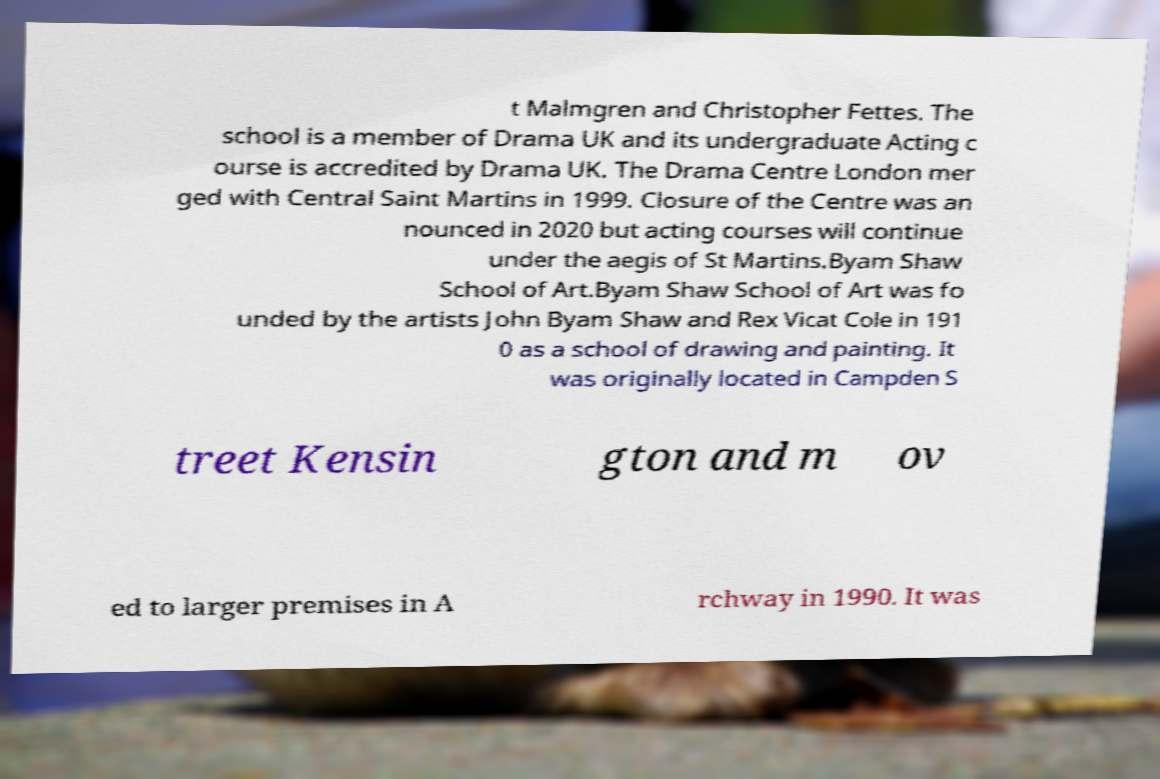There's text embedded in this image that I need extracted. Can you transcribe it verbatim? t Malmgren and Christopher Fettes. The school is a member of Drama UK and its undergraduate Acting c ourse is accredited by Drama UK. The Drama Centre London mer ged with Central Saint Martins in 1999. Closure of the Centre was an nounced in 2020 but acting courses will continue under the aegis of St Martins.Byam Shaw School of Art.Byam Shaw School of Art was fo unded by the artists John Byam Shaw and Rex Vicat Cole in 191 0 as a school of drawing and painting. It was originally located in Campden S treet Kensin gton and m ov ed to larger premises in A rchway in 1990. It was 